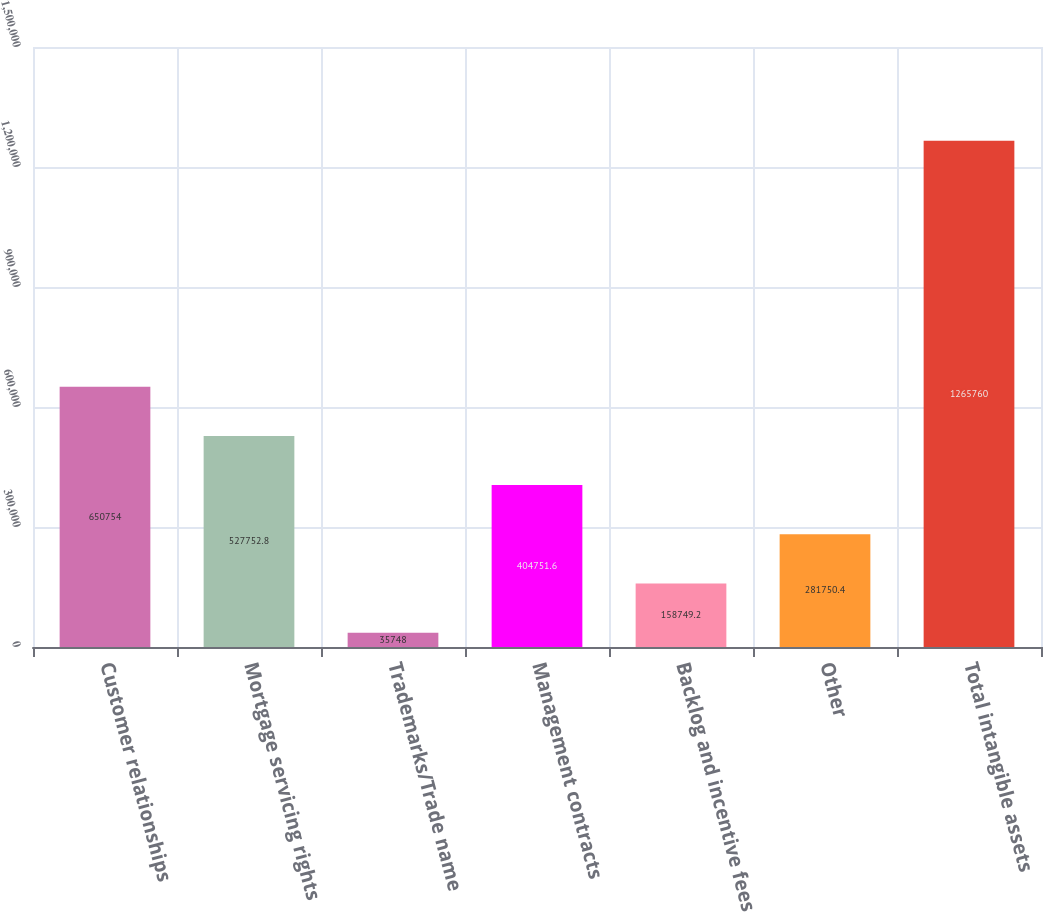<chart> <loc_0><loc_0><loc_500><loc_500><bar_chart><fcel>Customer relationships<fcel>Mortgage servicing rights<fcel>Trademarks/Trade name<fcel>Management contracts<fcel>Backlog and incentive fees<fcel>Other<fcel>Total intangible assets<nl><fcel>650754<fcel>527753<fcel>35748<fcel>404752<fcel>158749<fcel>281750<fcel>1.26576e+06<nl></chart> 